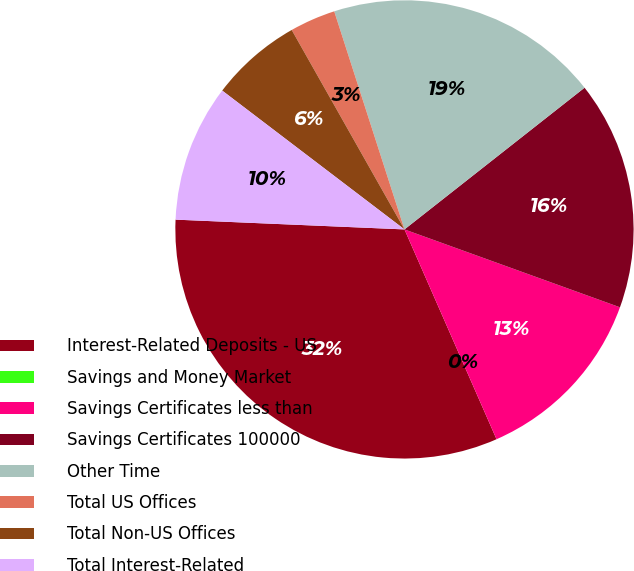<chart> <loc_0><loc_0><loc_500><loc_500><pie_chart><fcel>Interest-Related Deposits - US<fcel>Savings and Money Market<fcel>Savings Certificates less than<fcel>Savings Certificates 100000<fcel>Other Time<fcel>Total US Offices<fcel>Total Non-US Offices<fcel>Total Interest-Related<nl><fcel>32.26%<fcel>0.0%<fcel>12.9%<fcel>16.13%<fcel>19.35%<fcel>3.23%<fcel>6.45%<fcel>9.68%<nl></chart> 